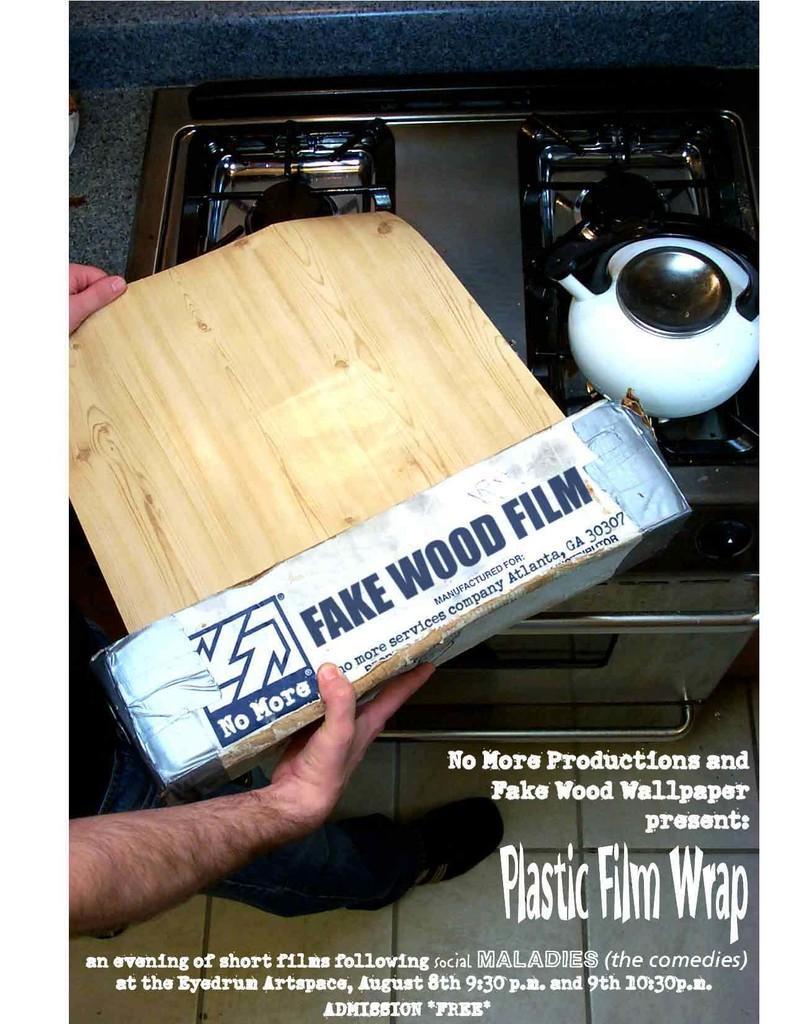Could you give a brief overview of what you see in this image? In this picture there are stove, teapot, a person standing and a fake wood film. At the bottom there is text. 